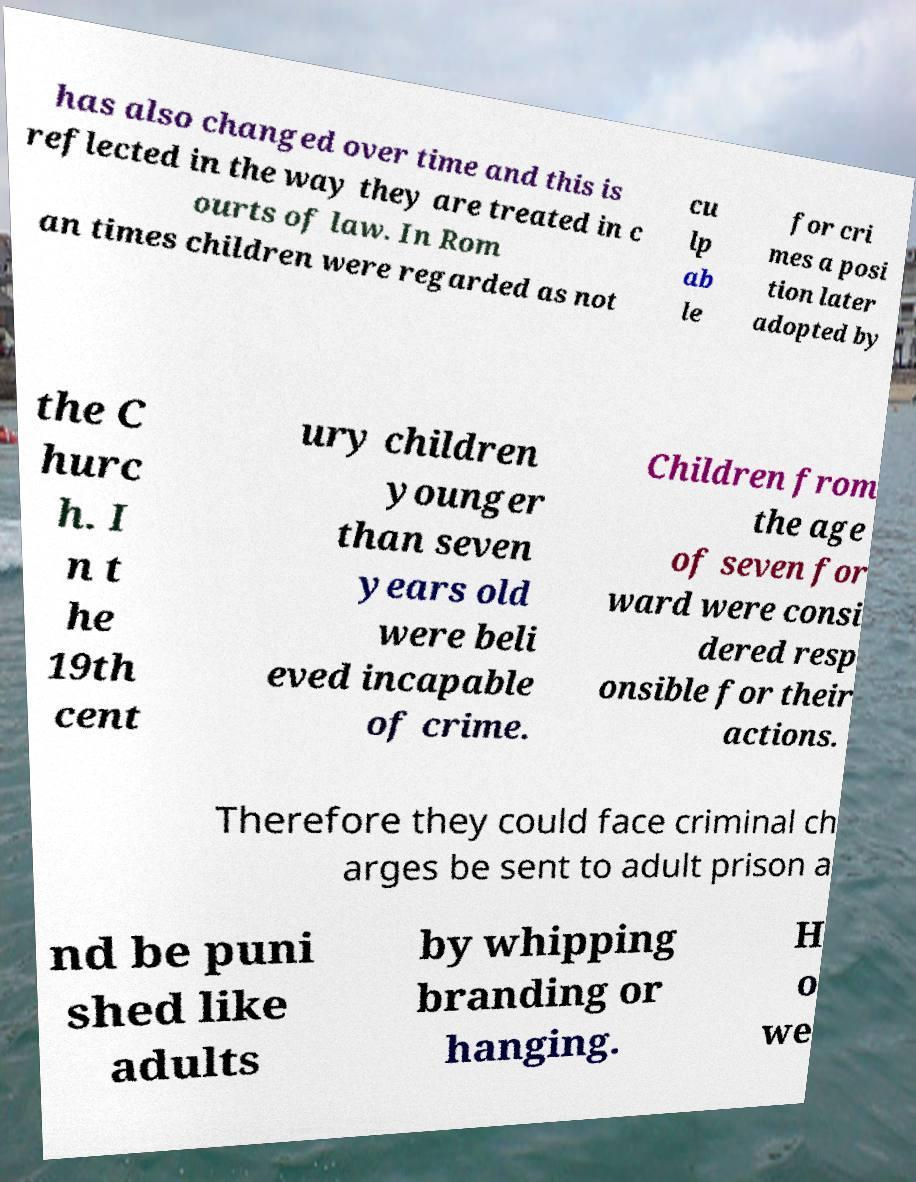Can you accurately transcribe the text from the provided image for me? has also changed over time and this is reflected in the way they are treated in c ourts of law. In Rom an times children were regarded as not cu lp ab le for cri mes a posi tion later adopted by the C hurc h. I n t he 19th cent ury children younger than seven years old were beli eved incapable of crime. Children from the age of seven for ward were consi dered resp onsible for their actions. Therefore they could face criminal ch arges be sent to adult prison a nd be puni shed like adults by whipping branding or hanging. H o we 